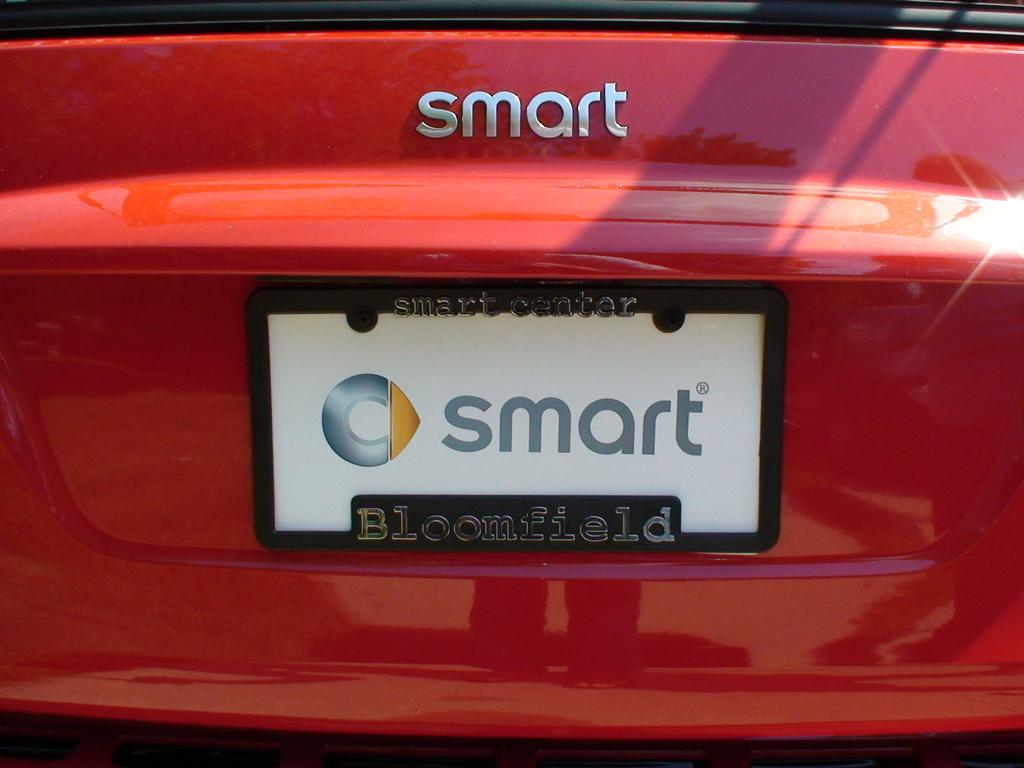<image>
Give a short and clear explanation of the subsequent image. The rear end of a red car says "smart" on it above a license plate that also says "smart" on it. 